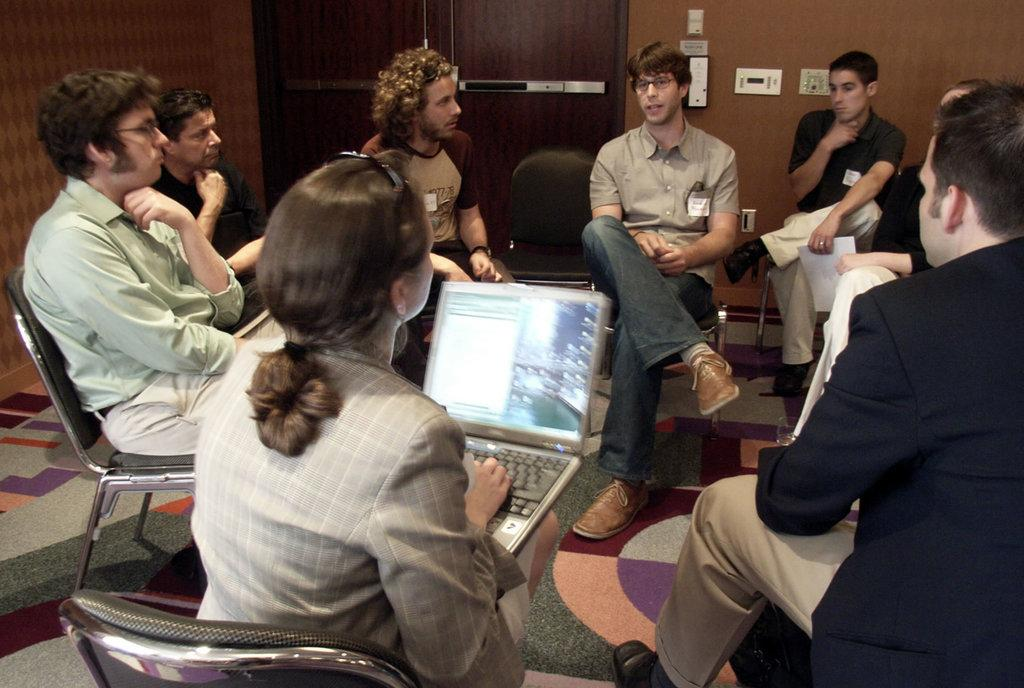What are the people in the image doing? The people in the image are sitting on chairs. What object is the lady holding in her hands? The lady is holding a laptop in her hands. What can be seen in the background of the image? There is a wall in the background of the image. What feature of the wall is visible in the image? There is a door in the wall in the background. Can you see a crowing on the chairs in the image? No, there is no crowing on the chairs in the image. 